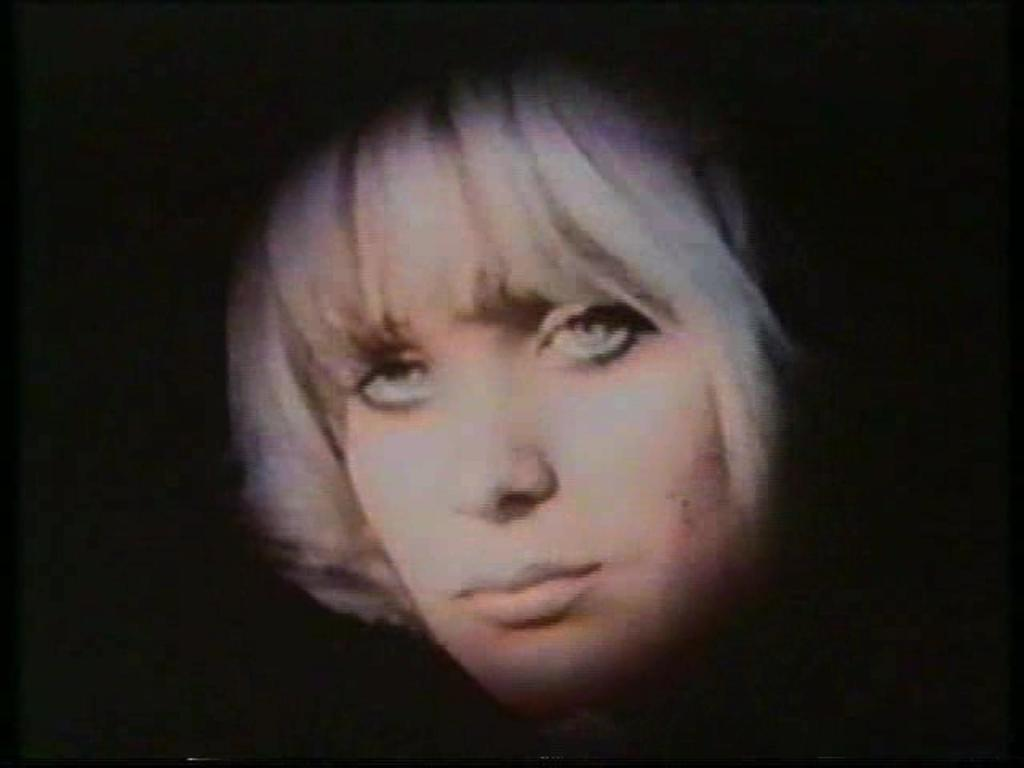What is the main subject of the image? There is a person's face in the image. What color is the background of the image? The background of the image is black. Where is the throne located in the image? There is no throne present in the image. What type of deer can be seen in the image? There are no deer present in the image. 